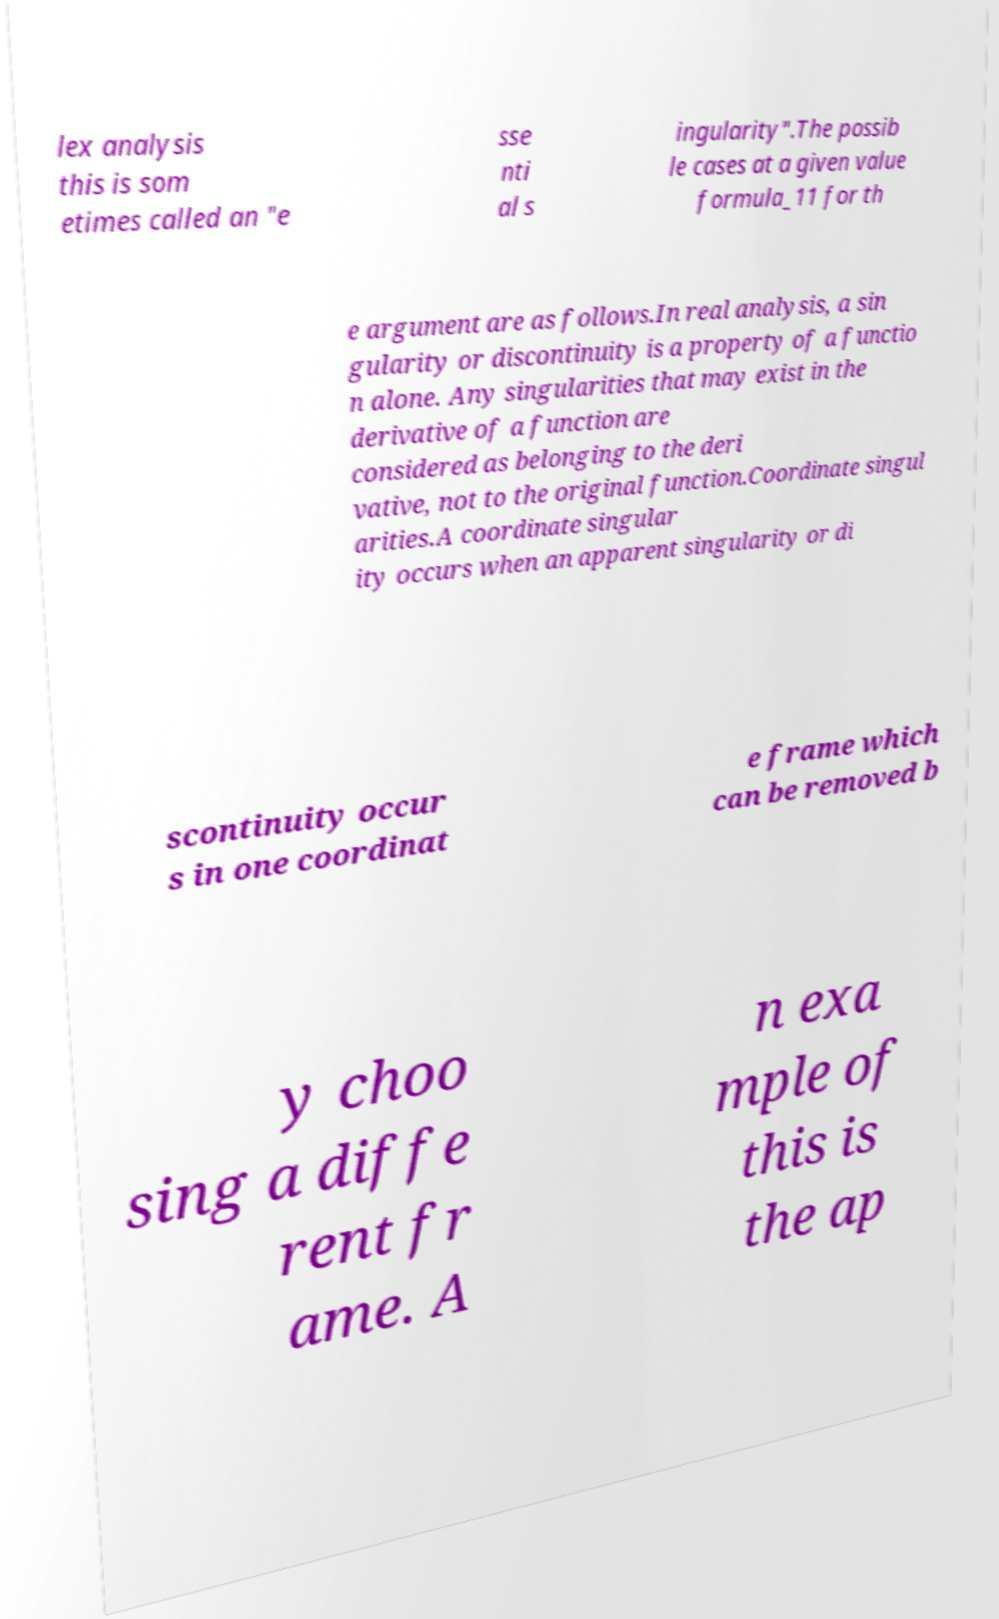Please identify and transcribe the text found in this image. lex analysis this is som etimes called an "e sse nti al s ingularity".The possib le cases at a given value formula_11 for th e argument are as follows.In real analysis, a sin gularity or discontinuity is a property of a functio n alone. Any singularities that may exist in the derivative of a function are considered as belonging to the deri vative, not to the original function.Coordinate singul arities.A coordinate singular ity occurs when an apparent singularity or di scontinuity occur s in one coordinat e frame which can be removed b y choo sing a diffe rent fr ame. A n exa mple of this is the ap 